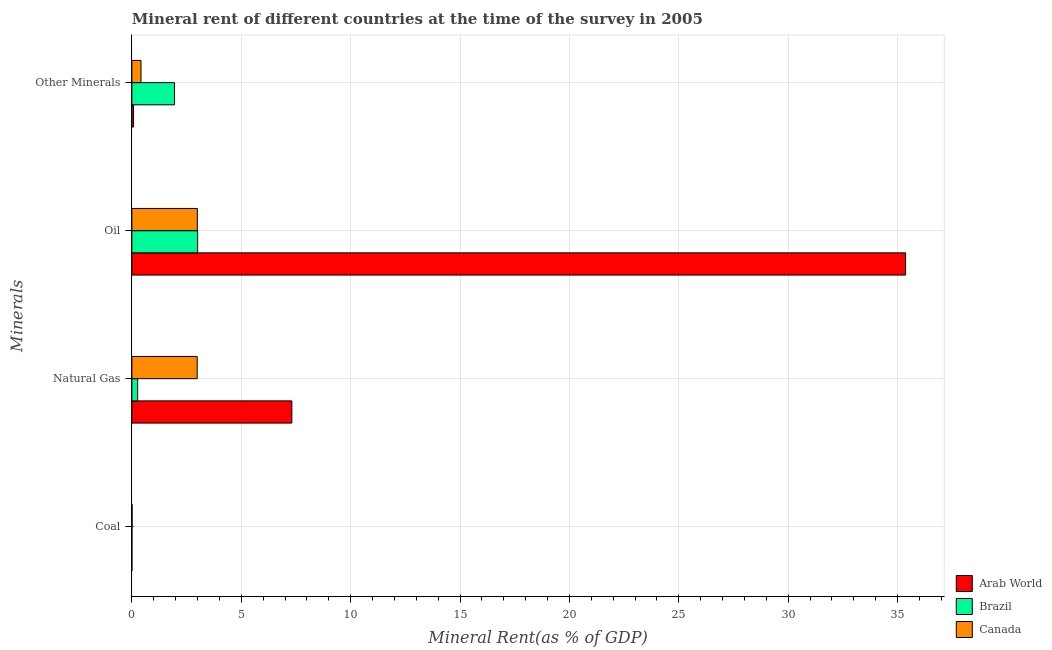Are the number of bars on each tick of the Y-axis equal?
Provide a short and direct response. Yes. How many bars are there on the 1st tick from the top?
Offer a very short reply. 3. What is the label of the 2nd group of bars from the top?
Ensure brevity in your answer.  Oil. What is the coal rent in Canada?
Your answer should be compact. 0.01. Across all countries, what is the maximum  rent of other minerals?
Give a very brief answer. 1.95. Across all countries, what is the minimum natural gas rent?
Give a very brief answer. 0.26. In which country was the coal rent maximum?
Give a very brief answer. Canada. What is the total natural gas rent in the graph?
Give a very brief answer. 10.56. What is the difference between the natural gas rent in Arab World and that in Brazil?
Offer a very short reply. 7.05. What is the difference between the natural gas rent in Canada and the oil rent in Brazil?
Keep it short and to the point. -0.02. What is the average coal rent per country?
Your answer should be very brief. 0. What is the difference between the  rent of other minerals and coal rent in Canada?
Give a very brief answer. 0.41. In how many countries, is the  rent of other minerals greater than 31 %?
Provide a short and direct response. 0. What is the ratio of the natural gas rent in Brazil to that in Canada?
Give a very brief answer. 0.09. Is the oil rent in Brazil less than that in Canada?
Give a very brief answer. No. Is the difference between the natural gas rent in Canada and Brazil greater than the difference between the coal rent in Canada and Brazil?
Your response must be concise. Yes. What is the difference between the highest and the second highest coal rent?
Make the answer very short. 0.01. What is the difference between the highest and the lowest natural gas rent?
Provide a succinct answer. 7.05. In how many countries, is the natural gas rent greater than the average natural gas rent taken over all countries?
Ensure brevity in your answer.  1. What does the 3rd bar from the top in Coal represents?
Your response must be concise. Arab World. What does the 3rd bar from the bottom in Coal represents?
Make the answer very short. Canada. What is the difference between two consecutive major ticks on the X-axis?
Your answer should be compact. 5. Are the values on the major ticks of X-axis written in scientific E-notation?
Your answer should be very brief. No. Does the graph contain grids?
Provide a succinct answer. Yes. How many legend labels are there?
Offer a terse response. 3. How are the legend labels stacked?
Your answer should be compact. Vertical. What is the title of the graph?
Provide a succinct answer. Mineral rent of different countries at the time of the survey in 2005. Does "Mongolia" appear as one of the legend labels in the graph?
Your answer should be very brief. No. What is the label or title of the X-axis?
Provide a succinct answer. Mineral Rent(as % of GDP). What is the label or title of the Y-axis?
Your answer should be compact. Minerals. What is the Mineral Rent(as % of GDP) in Arab World in Coal?
Give a very brief answer. 3.046739194078689e-5. What is the Mineral Rent(as % of GDP) in Brazil in Coal?
Provide a short and direct response. 0. What is the Mineral Rent(as % of GDP) of Canada in Coal?
Your answer should be compact. 0.01. What is the Mineral Rent(as % of GDP) of Arab World in Natural Gas?
Your answer should be compact. 7.31. What is the Mineral Rent(as % of GDP) of Brazil in Natural Gas?
Offer a very short reply. 0.26. What is the Mineral Rent(as % of GDP) in Canada in Natural Gas?
Provide a short and direct response. 2.99. What is the Mineral Rent(as % of GDP) in Arab World in Oil?
Give a very brief answer. 35.37. What is the Mineral Rent(as % of GDP) in Brazil in Oil?
Offer a terse response. 3.01. What is the Mineral Rent(as % of GDP) of Canada in Oil?
Give a very brief answer. 2.99. What is the Mineral Rent(as % of GDP) in Arab World in Other Minerals?
Provide a short and direct response. 0.08. What is the Mineral Rent(as % of GDP) in Brazil in Other Minerals?
Offer a terse response. 1.95. What is the Mineral Rent(as % of GDP) of Canada in Other Minerals?
Make the answer very short. 0.42. Across all Minerals, what is the maximum Mineral Rent(as % of GDP) in Arab World?
Make the answer very short. 35.37. Across all Minerals, what is the maximum Mineral Rent(as % of GDP) in Brazil?
Offer a very short reply. 3.01. Across all Minerals, what is the maximum Mineral Rent(as % of GDP) in Canada?
Provide a short and direct response. 2.99. Across all Minerals, what is the minimum Mineral Rent(as % of GDP) of Arab World?
Keep it short and to the point. 3.046739194078689e-5. Across all Minerals, what is the minimum Mineral Rent(as % of GDP) in Brazil?
Ensure brevity in your answer.  0. Across all Minerals, what is the minimum Mineral Rent(as % of GDP) in Canada?
Provide a succinct answer. 0.01. What is the total Mineral Rent(as % of GDP) of Arab World in the graph?
Provide a short and direct response. 42.76. What is the total Mineral Rent(as % of GDP) in Brazil in the graph?
Provide a succinct answer. 5.22. What is the total Mineral Rent(as % of GDP) in Canada in the graph?
Provide a short and direct response. 6.41. What is the difference between the Mineral Rent(as % of GDP) in Arab World in Coal and that in Natural Gas?
Offer a very short reply. -7.31. What is the difference between the Mineral Rent(as % of GDP) of Brazil in Coal and that in Natural Gas?
Give a very brief answer. -0.26. What is the difference between the Mineral Rent(as % of GDP) of Canada in Coal and that in Natural Gas?
Keep it short and to the point. -2.98. What is the difference between the Mineral Rent(as % of GDP) of Arab World in Coal and that in Oil?
Offer a terse response. -35.37. What is the difference between the Mineral Rent(as % of GDP) of Brazil in Coal and that in Oil?
Your answer should be very brief. -3.01. What is the difference between the Mineral Rent(as % of GDP) of Canada in Coal and that in Oil?
Give a very brief answer. -2.98. What is the difference between the Mineral Rent(as % of GDP) in Arab World in Coal and that in Other Minerals?
Give a very brief answer. -0.08. What is the difference between the Mineral Rent(as % of GDP) in Brazil in Coal and that in Other Minerals?
Your response must be concise. -1.95. What is the difference between the Mineral Rent(as % of GDP) in Canada in Coal and that in Other Minerals?
Your response must be concise. -0.41. What is the difference between the Mineral Rent(as % of GDP) of Arab World in Natural Gas and that in Oil?
Your response must be concise. -28.06. What is the difference between the Mineral Rent(as % of GDP) of Brazil in Natural Gas and that in Oil?
Keep it short and to the point. -2.74. What is the difference between the Mineral Rent(as % of GDP) in Canada in Natural Gas and that in Oil?
Offer a terse response. -0.01. What is the difference between the Mineral Rent(as % of GDP) in Arab World in Natural Gas and that in Other Minerals?
Offer a terse response. 7.24. What is the difference between the Mineral Rent(as % of GDP) in Brazil in Natural Gas and that in Other Minerals?
Keep it short and to the point. -1.69. What is the difference between the Mineral Rent(as % of GDP) of Canada in Natural Gas and that in Other Minerals?
Ensure brevity in your answer.  2.57. What is the difference between the Mineral Rent(as % of GDP) in Arab World in Oil and that in Other Minerals?
Make the answer very short. 35.29. What is the difference between the Mineral Rent(as % of GDP) of Brazil in Oil and that in Other Minerals?
Keep it short and to the point. 1.06. What is the difference between the Mineral Rent(as % of GDP) of Canada in Oil and that in Other Minerals?
Your answer should be very brief. 2.58. What is the difference between the Mineral Rent(as % of GDP) of Arab World in Coal and the Mineral Rent(as % of GDP) of Brazil in Natural Gas?
Make the answer very short. -0.26. What is the difference between the Mineral Rent(as % of GDP) in Arab World in Coal and the Mineral Rent(as % of GDP) in Canada in Natural Gas?
Give a very brief answer. -2.99. What is the difference between the Mineral Rent(as % of GDP) of Brazil in Coal and the Mineral Rent(as % of GDP) of Canada in Natural Gas?
Provide a short and direct response. -2.98. What is the difference between the Mineral Rent(as % of GDP) in Arab World in Coal and the Mineral Rent(as % of GDP) in Brazil in Oil?
Your answer should be very brief. -3.01. What is the difference between the Mineral Rent(as % of GDP) of Arab World in Coal and the Mineral Rent(as % of GDP) of Canada in Oil?
Give a very brief answer. -2.99. What is the difference between the Mineral Rent(as % of GDP) of Brazil in Coal and the Mineral Rent(as % of GDP) of Canada in Oil?
Make the answer very short. -2.99. What is the difference between the Mineral Rent(as % of GDP) of Arab World in Coal and the Mineral Rent(as % of GDP) of Brazil in Other Minerals?
Provide a short and direct response. -1.95. What is the difference between the Mineral Rent(as % of GDP) in Arab World in Coal and the Mineral Rent(as % of GDP) in Canada in Other Minerals?
Give a very brief answer. -0.42. What is the difference between the Mineral Rent(as % of GDP) of Brazil in Coal and the Mineral Rent(as % of GDP) of Canada in Other Minerals?
Your answer should be very brief. -0.42. What is the difference between the Mineral Rent(as % of GDP) of Arab World in Natural Gas and the Mineral Rent(as % of GDP) of Brazil in Oil?
Your response must be concise. 4.31. What is the difference between the Mineral Rent(as % of GDP) in Arab World in Natural Gas and the Mineral Rent(as % of GDP) in Canada in Oil?
Ensure brevity in your answer.  4.32. What is the difference between the Mineral Rent(as % of GDP) in Brazil in Natural Gas and the Mineral Rent(as % of GDP) in Canada in Oil?
Your answer should be compact. -2.73. What is the difference between the Mineral Rent(as % of GDP) in Arab World in Natural Gas and the Mineral Rent(as % of GDP) in Brazil in Other Minerals?
Give a very brief answer. 5.36. What is the difference between the Mineral Rent(as % of GDP) of Arab World in Natural Gas and the Mineral Rent(as % of GDP) of Canada in Other Minerals?
Offer a very short reply. 6.9. What is the difference between the Mineral Rent(as % of GDP) of Brazil in Natural Gas and the Mineral Rent(as % of GDP) of Canada in Other Minerals?
Provide a short and direct response. -0.15. What is the difference between the Mineral Rent(as % of GDP) of Arab World in Oil and the Mineral Rent(as % of GDP) of Brazil in Other Minerals?
Provide a short and direct response. 33.42. What is the difference between the Mineral Rent(as % of GDP) in Arab World in Oil and the Mineral Rent(as % of GDP) in Canada in Other Minerals?
Provide a short and direct response. 34.95. What is the difference between the Mineral Rent(as % of GDP) of Brazil in Oil and the Mineral Rent(as % of GDP) of Canada in Other Minerals?
Keep it short and to the point. 2.59. What is the average Mineral Rent(as % of GDP) in Arab World per Minerals?
Give a very brief answer. 10.69. What is the average Mineral Rent(as % of GDP) of Brazil per Minerals?
Ensure brevity in your answer.  1.31. What is the average Mineral Rent(as % of GDP) of Canada per Minerals?
Offer a terse response. 1.6. What is the difference between the Mineral Rent(as % of GDP) of Arab World and Mineral Rent(as % of GDP) of Brazil in Coal?
Your answer should be compact. -0. What is the difference between the Mineral Rent(as % of GDP) in Arab World and Mineral Rent(as % of GDP) in Canada in Coal?
Ensure brevity in your answer.  -0.01. What is the difference between the Mineral Rent(as % of GDP) in Brazil and Mineral Rent(as % of GDP) in Canada in Coal?
Provide a succinct answer. -0.01. What is the difference between the Mineral Rent(as % of GDP) in Arab World and Mineral Rent(as % of GDP) in Brazil in Natural Gas?
Ensure brevity in your answer.  7.05. What is the difference between the Mineral Rent(as % of GDP) in Arab World and Mineral Rent(as % of GDP) in Canada in Natural Gas?
Your response must be concise. 4.33. What is the difference between the Mineral Rent(as % of GDP) in Brazil and Mineral Rent(as % of GDP) in Canada in Natural Gas?
Keep it short and to the point. -2.72. What is the difference between the Mineral Rent(as % of GDP) of Arab World and Mineral Rent(as % of GDP) of Brazil in Oil?
Give a very brief answer. 32.36. What is the difference between the Mineral Rent(as % of GDP) of Arab World and Mineral Rent(as % of GDP) of Canada in Oil?
Make the answer very short. 32.38. What is the difference between the Mineral Rent(as % of GDP) in Brazil and Mineral Rent(as % of GDP) in Canada in Oil?
Make the answer very short. 0.01. What is the difference between the Mineral Rent(as % of GDP) in Arab World and Mineral Rent(as % of GDP) in Brazil in Other Minerals?
Offer a very short reply. -1.87. What is the difference between the Mineral Rent(as % of GDP) in Arab World and Mineral Rent(as % of GDP) in Canada in Other Minerals?
Offer a very short reply. -0.34. What is the difference between the Mineral Rent(as % of GDP) of Brazil and Mineral Rent(as % of GDP) of Canada in Other Minerals?
Offer a very short reply. 1.53. What is the ratio of the Mineral Rent(as % of GDP) in Arab World in Coal to that in Natural Gas?
Offer a terse response. 0. What is the ratio of the Mineral Rent(as % of GDP) in Brazil in Coal to that in Natural Gas?
Provide a short and direct response. 0. What is the ratio of the Mineral Rent(as % of GDP) of Canada in Coal to that in Natural Gas?
Give a very brief answer. 0. What is the ratio of the Mineral Rent(as % of GDP) in Brazil in Coal to that in Oil?
Your response must be concise. 0. What is the ratio of the Mineral Rent(as % of GDP) of Canada in Coal to that in Oil?
Make the answer very short. 0. What is the ratio of the Mineral Rent(as % of GDP) in Arab World in Coal to that in Other Minerals?
Give a very brief answer. 0. What is the ratio of the Mineral Rent(as % of GDP) of Brazil in Coal to that in Other Minerals?
Offer a terse response. 0. What is the ratio of the Mineral Rent(as % of GDP) of Canada in Coal to that in Other Minerals?
Provide a succinct answer. 0.02. What is the ratio of the Mineral Rent(as % of GDP) in Arab World in Natural Gas to that in Oil?
Give a very brief answer. 0.21. What is the ratio of the Mineral Rent(as % of GDP) of Brazil in Natural Gas to that in Oil?
Offer a terse response. 0.09. What is the ratio of the Mineral Rent(as % of GDP) of Arab World in Natural Gas to that in Other Minerals?
Provide a succinct answer. 96.62. What is the ratio of the Mineral Rent(as % of GDP) in Brazil in Natural Gas to that in Other Minerals?
Provide a short and direct response. 0.14. What is the ratio of the Mineral Rent(as % of GDP) of Canada in Natural Gas to that in Other Minerals?
Make the answer very short. 7.16. What is the ratio of the Mineral Rent(as % of GDP) of Arab World in Oil to that in Other Minerals?
Provide a short and direct response. 467.35. What is the ratio of the Mineral Rent(as % of GDP) of Brazil in Oil to that in Other Minerals?
Ensure brevity in your answer.  1.54. What is the ratio of the Mineral Rent(as % of GDP) in Canada in Oil to that in Other Minerals?
Offer a terse response. 7.17. What is the difference between the highest and the second highest Mineral Rent(as % of GDP) of Arab World?
Your answer should be compact. 28.06. What is the difference between the highest and the second highest Mineral Rent(as % of GDP) in Brazil?
Ensure brevity in your answer.  1.06. What is the difference between the highest and the second highest Mineral Rent(as % of GDP) of Canada?
Keep it short and to the point. 0.01. What is the difference between the highest and the lowest Mineral Rent(as % of GDP) in Arab World?
Keep it short and to the point. 35.37. What is the difference between the highest and the lowest Mineral Rent(as % of GDP) of Brazil?
Your answer should be compact. 3.01. What is the difference between the highest and the lowest Mineral Rent(as % of GDP) in Canada?
Offer a very short reply. 2.98. 